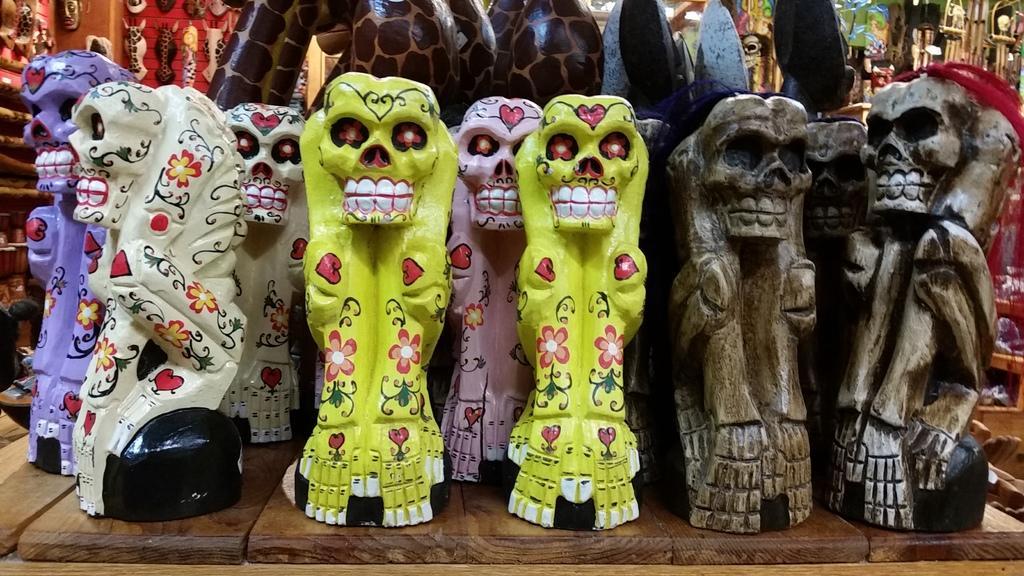Please provide a concise description of this image. In this image I can see sculptures are on the wooden surface. 